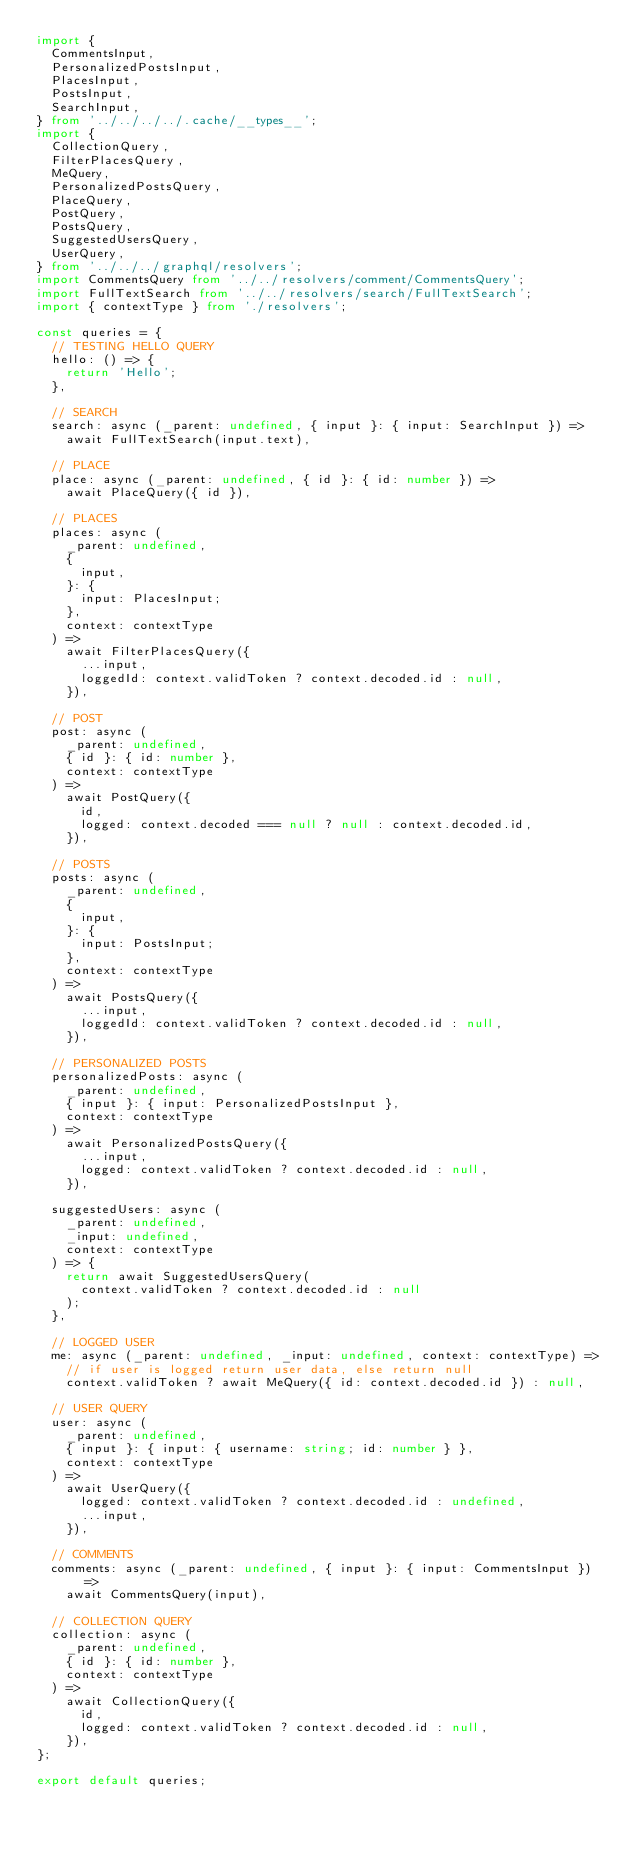<code> <loc_0><loc_0><loc_500><loc_500><_TypeScript_>import {
  CommentsInput,
  PersonalizedPostsInput,
  PlacesInput,
  PostsInput,
  SearchInput,
} from '../../../../.cache/__types__';
import {
  CollectionQuery,
  FilterPlacesQuery,
  MeQuery,
  PersonalizedPostsQuery,
  PlaceQuery,
  PostQuery,
  PostsQuery,
  SuggestedUsersQuery,
  UserQuery,
} from '../../../graphql/resolvers';
import CommentsQuery from '../../resolvers/comment/CommentsQuery';
import FullTextSearch from '../../resolvers/search/FullTextSearch';
import { contextType } from './resolvers';

const queries = {
  // TESTING HELLO QUERY
  hello: () => {
    return 'Hello';
  },

  // SEARCH
  search: async (_parent: undefined, { input }: { input: SearchInput }) =>
    await FullTextSearch(input.text),

  // PLACE
  place: async (_parent: undefined, { id }: { id: number }) =>
    await PlaceQuery({ id }),

  // PLACES
  places: async (
    _parent: undefined,
    {
      input,
    }: {
      input: PlacesInput;
    },
    context: contextType
  ) =>
    await FilterPlacesQuery({
      ...input,
      loggedId: context.validToken ? context.decoded.id : null,
    }),

  // POST
  post: async (
    _parent: undefined,
    { id }: { id: number },
    context: contextType
  ) =>
    await PostQuery({
      id,
      logged: context.decoded === null ? null : context.decoded.id,
    }),

  // POSTS
  posts: async (
    _parent: undefined,
    {
      input,
    }: {
      input: PostsInput;
    },
    context: contextType
  ) =>
    await PostsQuery({
      ...input,
      loggedId: context.validToken ? context.decoded.id : null,
    }),

  // PERSONALIZED POSTS
  personalizedPosts: async (
    _parent: undefined,
    { input }: { input: PersonalizedPostsInput },
    context: contextType
  ) =>
    await PersonalizedPostsQuery({
      ...input,
      logged: context.validToken ? context.decoded.id : null,
    }),

  suggestedUsers: async (
    _parent: undefined,
    _input: undefined,
    context: contextType
  ) => {
    return await SuggestedUsersQuery(
      context.validToken ? context.decoded.id : null
    );
  },

  // LOGGED USER
  me: async (_parent: undefined, _input: undefined, context: contextType) =>
    // if user is logged return user data, else return null
    context.validToken ? await MeQuery({ id: context.decoded.id }) : null,

  // USER QUERY
  user: async (
    _parent: undefined,
    { input }: { input: { username: string; id: number } },
    context: contextType
  ) =>
    await UserQuery({
      logged: context.validToken ? context.decoded.id : undefined,
      ...input,
    }),

  // COMMENTS
  comments: async (_parent: undefined, { input }: { input: CommentsInput }) =>
    await CommentsQuery(input),

  // COLLECTION QUERY
  collection: async (
    _parent: undefined,
    { id }: { id: number },
    context: contextType
  ) =>
    await CollectionQuery({
      id,
      logged: context.validToken ? context.decoded.id : null,
    }),
};

export default queries;
</code> 